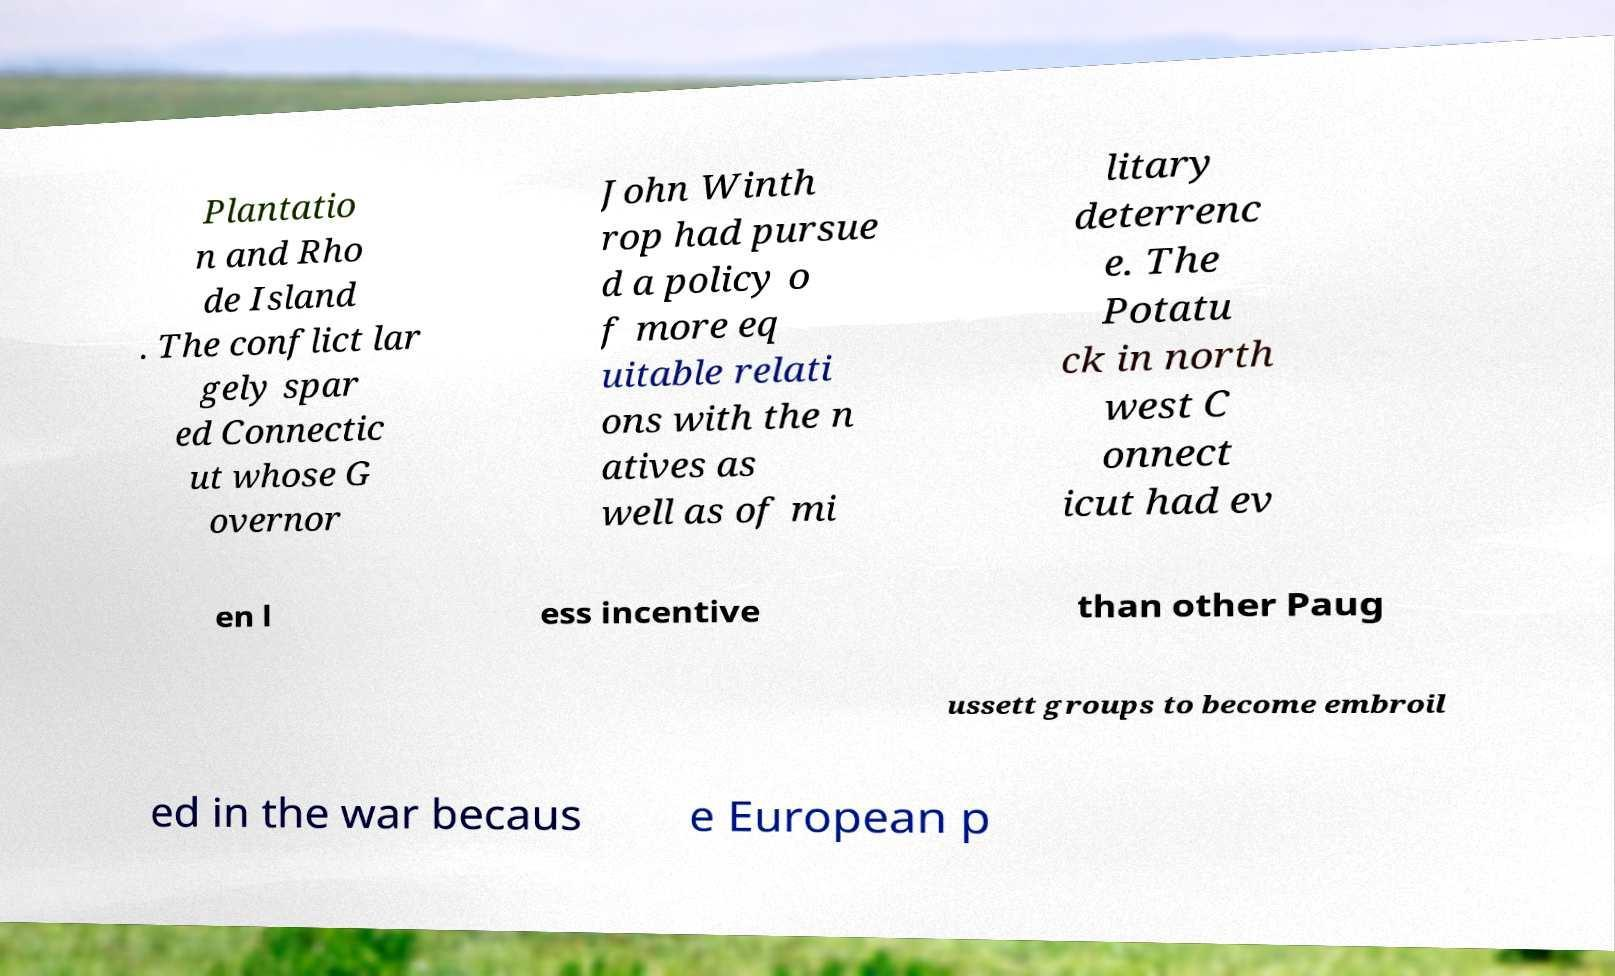Could you extract and type out the text from this image? Plantatio n and Rho de Island . The conflict lar gely spar ed Connectic ut whose G overnor John Winth rop had pursue d a policy o f more eq uitable relati ons with the n atives as well as of mi litary deterrenc e. The Potatu ck in north west C onnect icut had ev en l ess incentive than other Paug ussett groups to become embroil ed in the war becaus e European p 